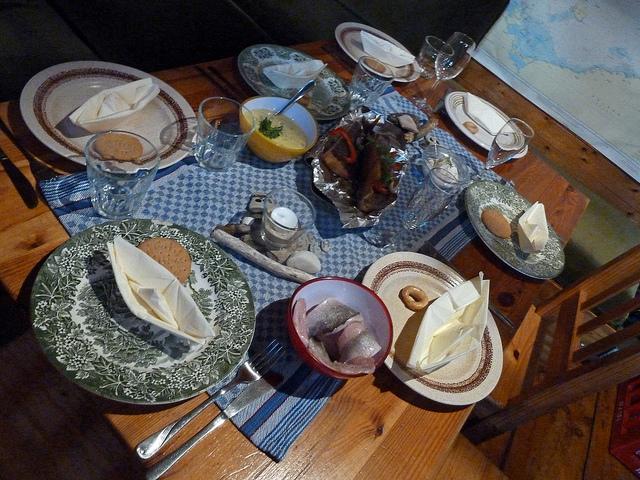Is this a restaurant or home  and which curry is kept on table?
Write a very short answer. Home. Are the drinking glasses full or empty?
Write a very short answer. Empty. How many dishes are on the table?
Keep it brief. 9. 